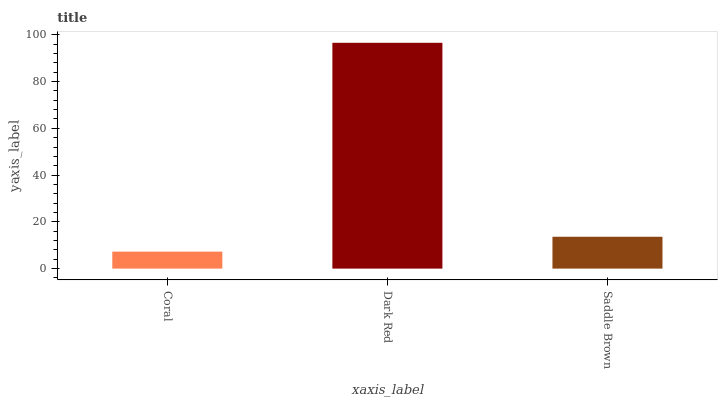Is Coral the minimum?
Answer yes or no. Yes. Is Dark Red the maximum?
Answer yes or no. Yes. Is Saddle Brown the minimum?
Answer yes or no. No. Is Saddle Brown the maximum?
Answer yes or no. No. Is Dark Red greater than Saddle Brown?
Answer yes or no. Yes. Is Saddle Brown less than Dark Red?
Answer yes or no. Yes. Is Saddle Brown greater than Dark Red?
Answer yes or no. No. Is Dark Red less than Saddle Brown?
Answer yes or no. No. Is Saddle Brown the high median?
Answer yes or no. Yes. Is Saddle Brown the low median?
Answer yes or no. Yes. Is Coral the high median?
Answer yes or no. No. Is Coral the low median?
Answer yes or no. No. 